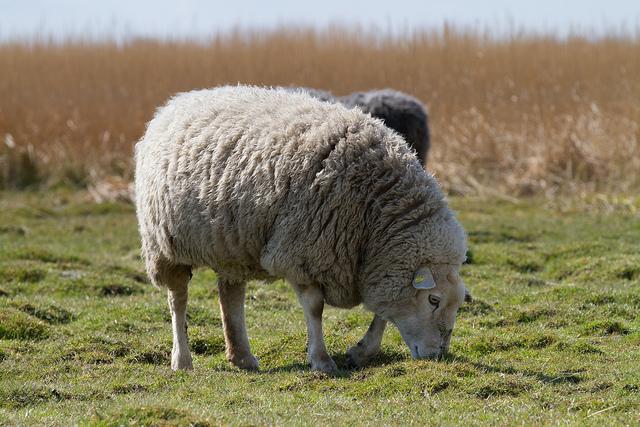Is the sheep bleeding?
Write a very short answer. No. How many garden hoses are there?
Answer briefly. 0. What is the sheep looking at?
Short answer required. Grass. Is the animal in the picture laying down?
Answer briefly. No. Is the sheep hot?
Answer briefly. Yes. Are there baby sheep in the picture?
Be succinct. No. Is there a second sheep standing behind this one?
Be succinct. Yes. What color is the face of the sheep in the picture?
Give a very brief answer. White. 